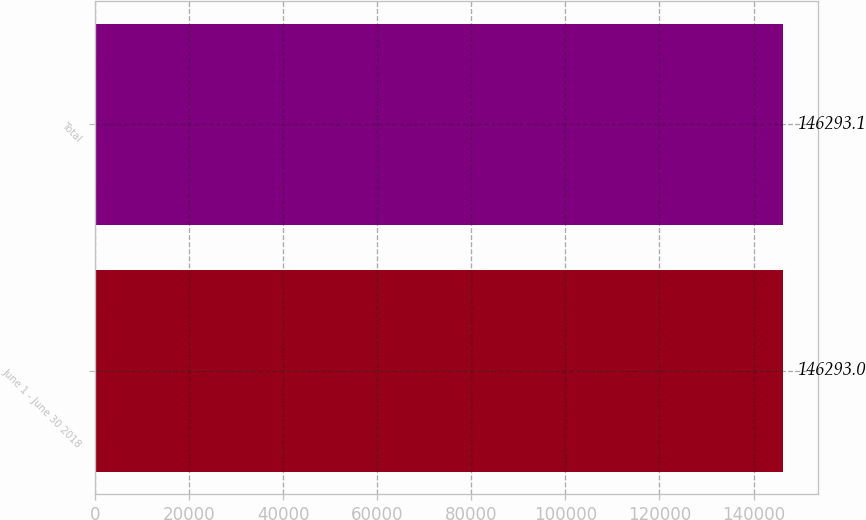Convert chart to OTSL. <chart><loc_0><loc_0><loc_500><loc_500><bar_chart><fcel>June 1 - June 30 2018<fcel>Total<nl><fcel>146293<fcel>146293<nl></chart> 